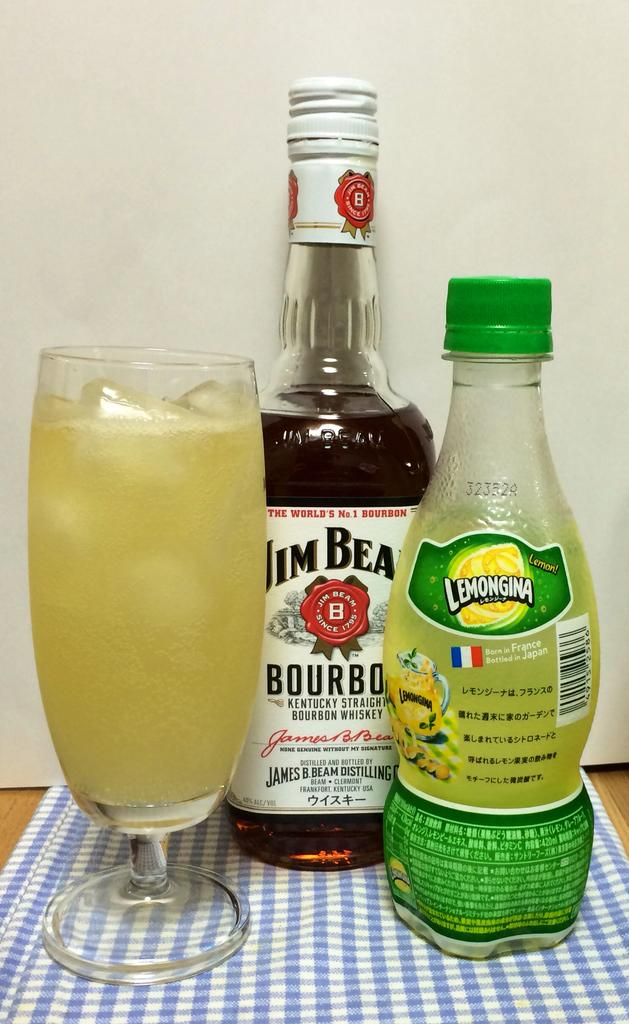Provide a one-sentence caption for the provided image. A bottle of bourbon, a bottle of lemon juice, sit next to a glass filled to the top with ice and liquid. 